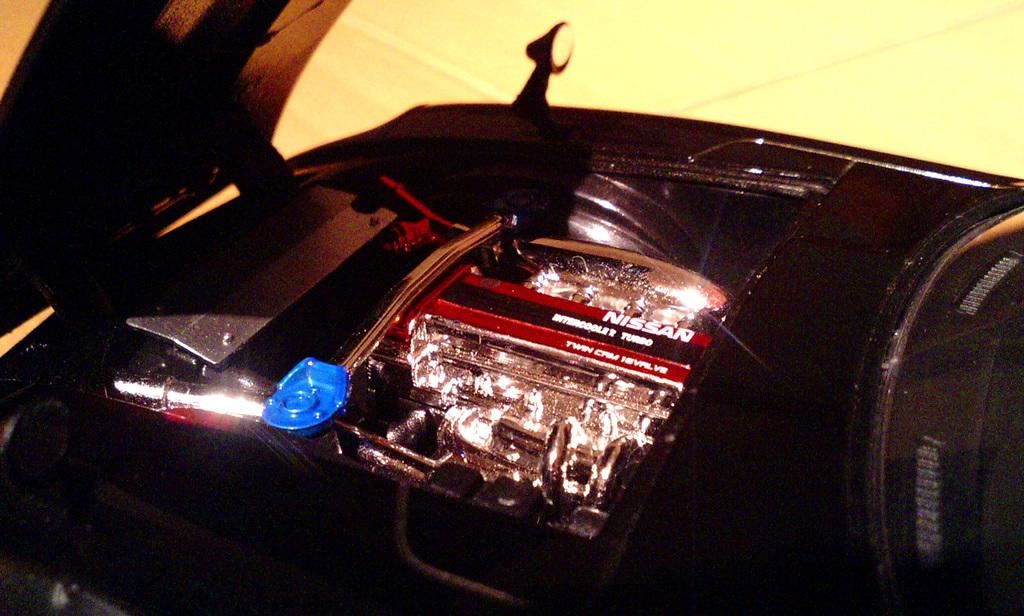What is the main subject of the picture? The main subject of the picture is an engine part of a car. Can you describe any other objects in the picture? Yes, there is a bonnet on the left side of the picture. What type of bike is parked next to the car engine in the picture? There is no bike present in the picture; it only features an engine part of a car and a bonnet. What reward is being given to the person who fixed the car engine in the picture? There is no indication of a reward or any people in the picture; it only shows an engine part of a car and a bonnet. 